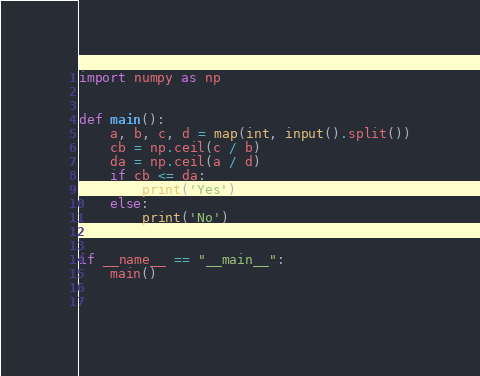Convert code to text. <code><loc_0><loc_0><loc_500><loc_500><_Python_>import numpy as np


def main():
    a, b, c, d = map(int, input().split())
    cb = np.ceil(c / b)
    da = np.ceil(a / d)
    if cb <= da:
        print('Yes')
    else:
        print('No')


if __name__ == "__main__":
    main()

 </code> 